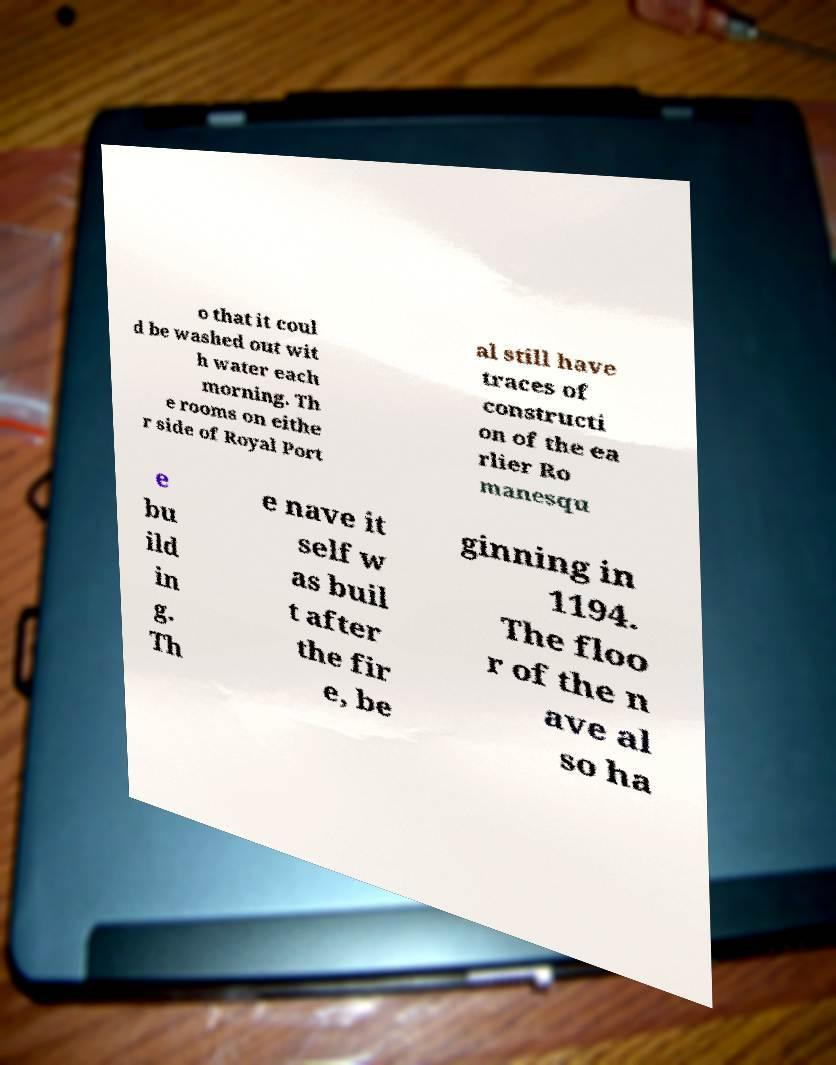There's text embedded in this image that I need extracted. Can you transcribe it verbatim? o that it coul d be washed out wit h water each morning. Th e rooms on eithe r side of Royal Port al still have traces of constructi on of the ea rlier Ro manesqu e bu ild in g. Th e nave it self w as buil t after the fir e, be ginning in 1194. The floo r of the n ave al so ha 